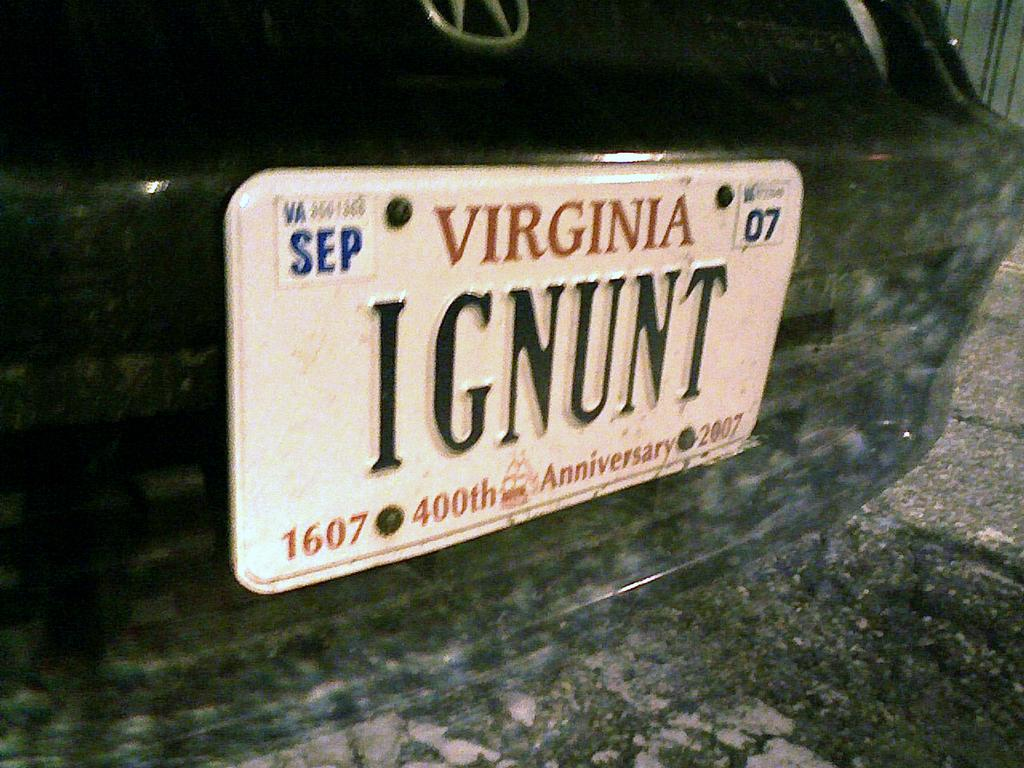Provide a one-sentence caption for the provided image. A Virginia license plate with IGNUNT on it. 